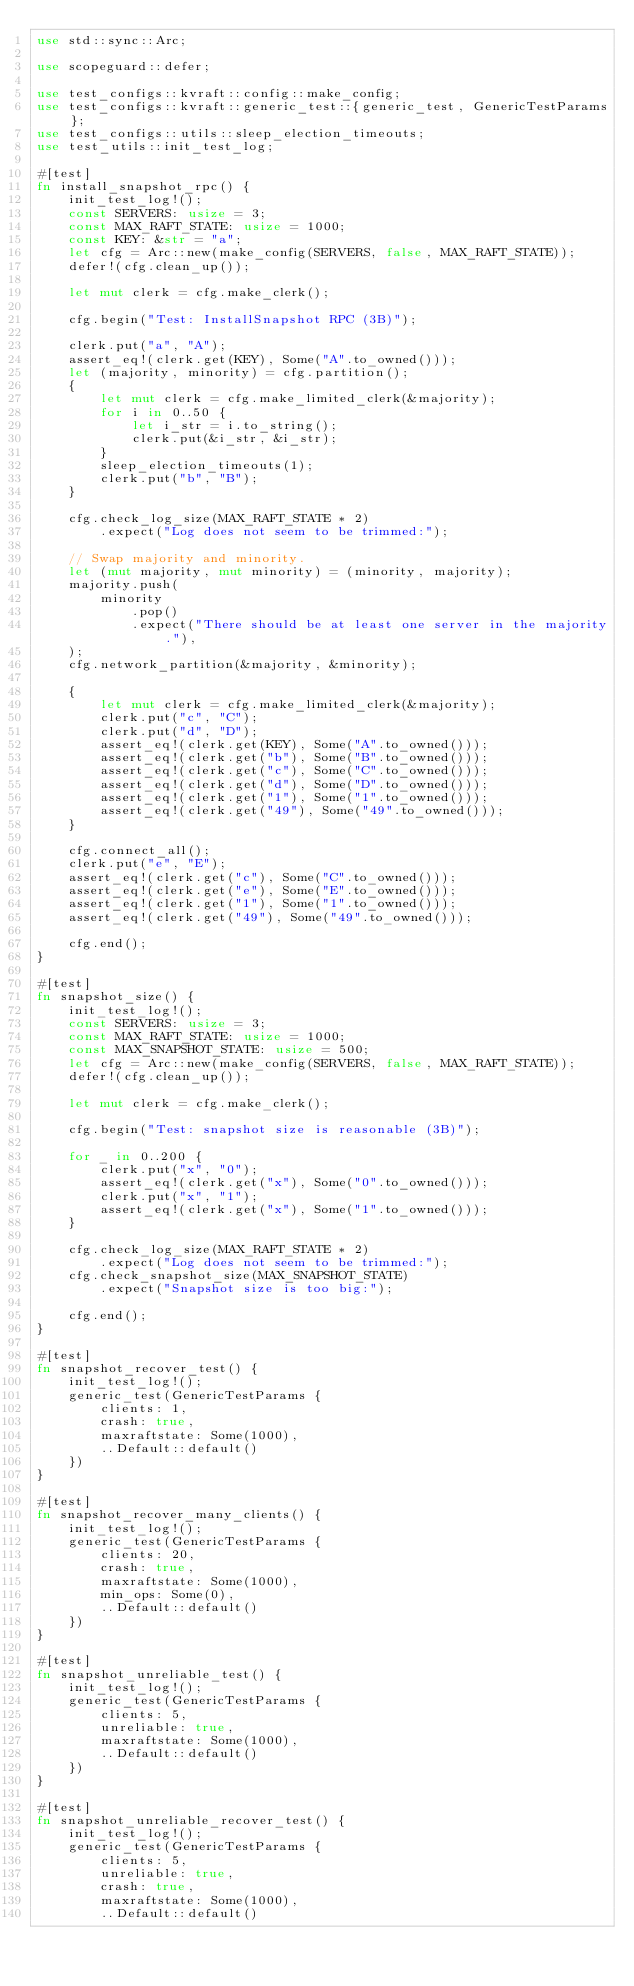<code> <loc_0><loc_0><loc_500><loc_500><_Rust_>use std::sync::Arc;

use scopeguard::defer;

use test_configs::kvraft::config::make_config;
use test_configs::kvraft::generic_test::{generic_test, GenericTestParams};
use test_configs::utils::sleep_election_timeouts;
use test_utils::init_test_log;

#[test]
fn install_snapshot_rpc() {
    init_test_log!();
    const SERVERS: usize = 3;
    const MAX_RAFT_STATE: usize = 1000;
    const KEY: &str = "a";
    let cfg = Arc::new(make_config(SERVERS, false, MAX_RAFT_STATE));
    defer!(cfg.clean_up());

    let mut clerk = cfg.make_clerk();

    cfg.begin("Test: InstallSnapshot RPC (3B)");

    clerk.put("a", "A");
    assert_eq!(clerk.get(KEY), Some("A".to_owned()));
    let (majority, minority) = cfg.partition();
    {
        let mut clerk = cfg.make_limited_clerk(&majority);
        for i in 0..50 {
            let i_str = i.to_string();
            clerk.put(&i_str, &i_str);
        }
        sleep_election_timeouts(1);
        clerk.put("b", "B");
    }

    cfg.check_log_size(MAX_RAFT_STATE * 2)
        .expect("Log does not seem to be trimmed:");

    // Swap majority and minority.
    let (mut majority, mut minority) = (minority, majority);
    majority.push(
        minority
            .pop()
            .expect("There should be at least one server in the majority."),
    );
    cfg.network_partition(&majority, &minority);

    {
        let mut clerk = cfg.make_limited_clerk(&majority);
        clerk.put("c", "C");
        clerk.put("d", "D");
        assert_eq!(clerk.get(KEY), Some("A".to_owned()));
        assert_eq!(clerk.get("b"), Some("B".to_owned()));
        assert_eq!(clerk.get("c"), Some("C".to_owned()));
        assert_eq!(clerk.get("d"), Some("D".to_owned()));
        assert_eq!(clerk.get("1"), Some("1".to_owned()));
        assert_eq!(clerk.get("49"), Some("49".to_owned()));
    }

    cfg.connect_all();
    clerk.put("e", "E");
    assert_eq!(clerk.get("c"), Some("C".to_owned()));
    assert_eq!(clerk.get("e"), Some("E".to_owned()));
    assert_eq!(clerk.get("1"), Some("1".to_owned()));
    assert_eq!(clerk.get("49"), Some("49".to_owned()));

    cfg.end();
}

#[test]
fn snapshot_size() {
    init_test_log!();
    const SERVERS: usize = 3;
    const MAX_RAFT_STATE: usize = 1000;
    const MAX_SNAPSHOT_STATE: usize = 500;
    let cfg = Arc::new(make_config(SERVERS, false, MAX_RAFT_STATE));
    defer!(cfg.clean_up());

    let mut clerk = cfg.make_clerk();

    cfg.begin("Test: snapshot size is reasonable (3B)");

    for _ in 0..200 {
        clerk.put("x", "0");
        assert_eq!(clerk.get("x"), Some("0".to_owned()));
        clerk.put("x", "1");
        assert_eq!(clerk.get("x"), Some("1".to_owned()));
    }

    cfg.check_log_size(MAX_RAFT_STATE * 2)
        .expect("Log does not seem to be trimmed:");
    cfg.check_snapshot_size(MAX_SNAPSHOT_STATE)
        .expect("Snapshot size is too big:");

    cfg.end();
}

#[test]
fn snapshot_recover_test() {
    init_test_log!();
    generic_test(GenericTestParams {
        clients: 1,
        crash: true,
        maxraftstate: Some(1000),
        ..Default::default()
    })
}

#[test]
fn snapshot_recover_many_clients() {
    init_test_log!();
    generic_test(GenericTestParams {
        clients: 20,
        crash: true,
        maxraftstate: Some(1000),
        min_ops: Some(0),
        ..Default::default()
    })
}

#[test]
fn snapshot_unreliable_test() {
    init_test_log!();
    generic_test(GenericTestParams {
        clients: 5,
        unreliable: true,
        maxraftstate: Some(1000),
        ..Default::default()
    })
}

#[test]
fn snapshot_unreliable_recover_test() {
    init_test_log!();
    generic_test(GenericTestParams {
        clients: 5,
        unreliable: true,
        crash: true,
        maxraftstate: Some(1000),
        ..Default::default()</code> 